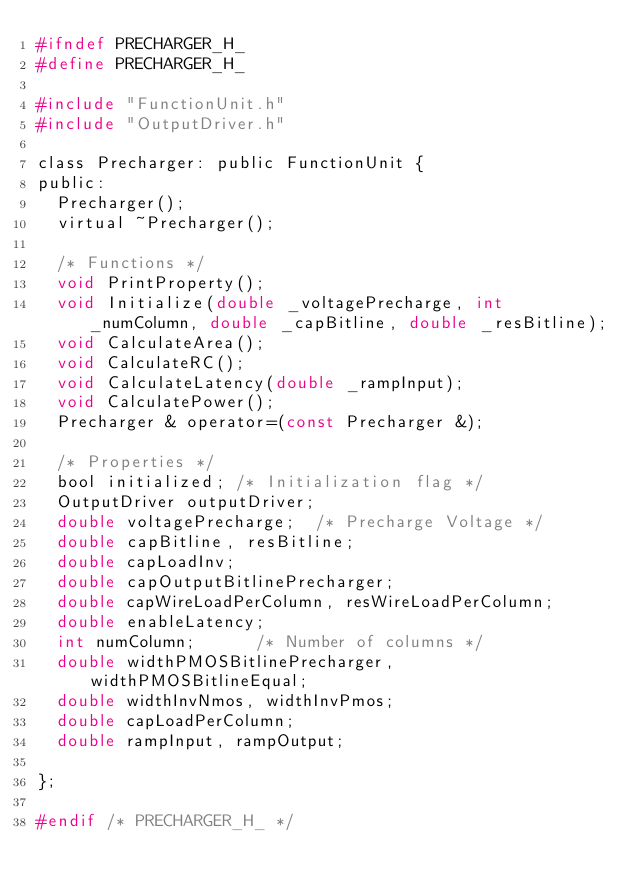Convert code to text. <code><loc_0><loc_0><loc_500><loc_500><_C_>#ifndef PRECHARGER_H_
#define PRECHARGER_H_

#include "FunctionUnit.h"
#include "OutputDriver.h"

class Precharger: public FunctionUnit {
public:
	Precharger();
	virtual ~Precharger();

	/* Functions */
	void PrintProperty();
	void Initialize(double _voltagePrecharge, int _numColumn, double _capBitline, double _resBitline);
	void CalculateArea();
	void CalculateRC();
	void CalculateLatency(double _rampInput);
	void CalculatePower();
	Precharger & operator=(const Precharger &);

	/* Properties */
	bool initialized;	/* Initialization flag */
	OutputDriver outputDriver;
	double voltagePrecharge;  /* Precharge Voltage */
	double capBitline, resBitline;
	double capLoadInv;
	double capOutputBitlinePrecharger;
	double capWireLoadPerColumn, resWireLoadPerColumn;
	double enableLatency;
	int numColumn;			/* Number of columns */
	double widthPMOSBitlinePrecharger, widthPMOSBitlineEqual;
	double widthInvNmos, widthInvPmos;
	double capLoadPerColumn;
	double rampInput, rampOutput;

};

#endif /* PRECHARGER_H_ */
</code> 